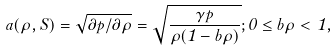<formula> <loc_0><loc_0><loc_500><loc_500>a ( \rho , { S } ) = \sqrt { \partial { p } / \partial { \rho } } = \sqrt { \frac { { \gamma } p } { \rho ( 1 - b \rho ) } } ; 0 \leq { b \rho } < 1 ,</formula> 